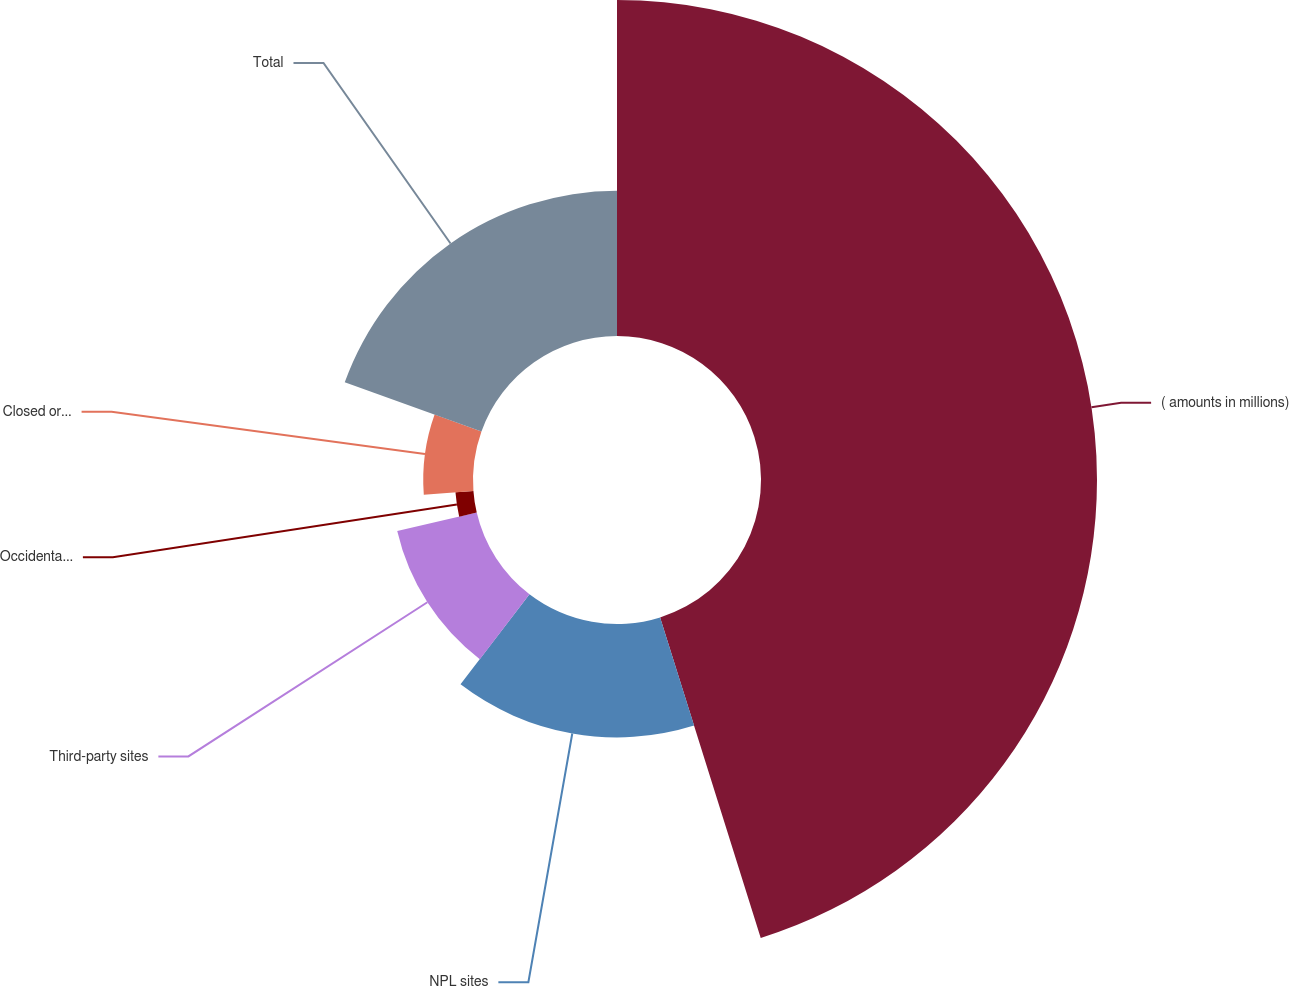<chart> <loc_0><loc_0><loc_500><loc_500><pie_chart><fcel>( amounts in millions)<fcel>NPL sites<fcel>Third-party sites<fcel>Occidental- operated sites<fcel>Closed or non- operated<fcel>Total<nl><fcel>45.16%<fcel>15.24%<fcel>10.97%<fcel>2.42%<fcel>6.69%<fcel>19.52%<nl></chart> 